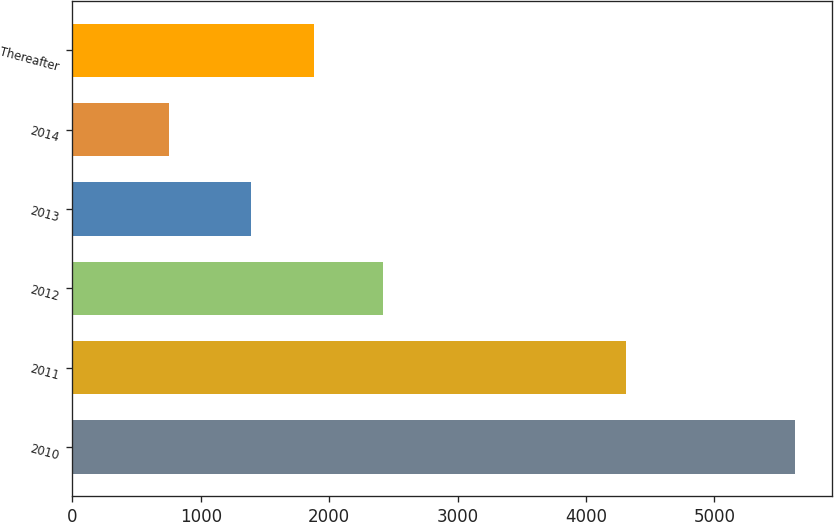Convert chart to OTSL. <chart><loc_0><loc_0><loc_500><loc_500><bar_chart><fcel>2010<fcel>2011<fcel>2012<fcel>2013<fcel>2014<fcel>Thereafter<nl><fcel>5631<fcel>4312<fcel>2422<fcel>1391<fcel>753<fcel>1878.8<nl></chart> 